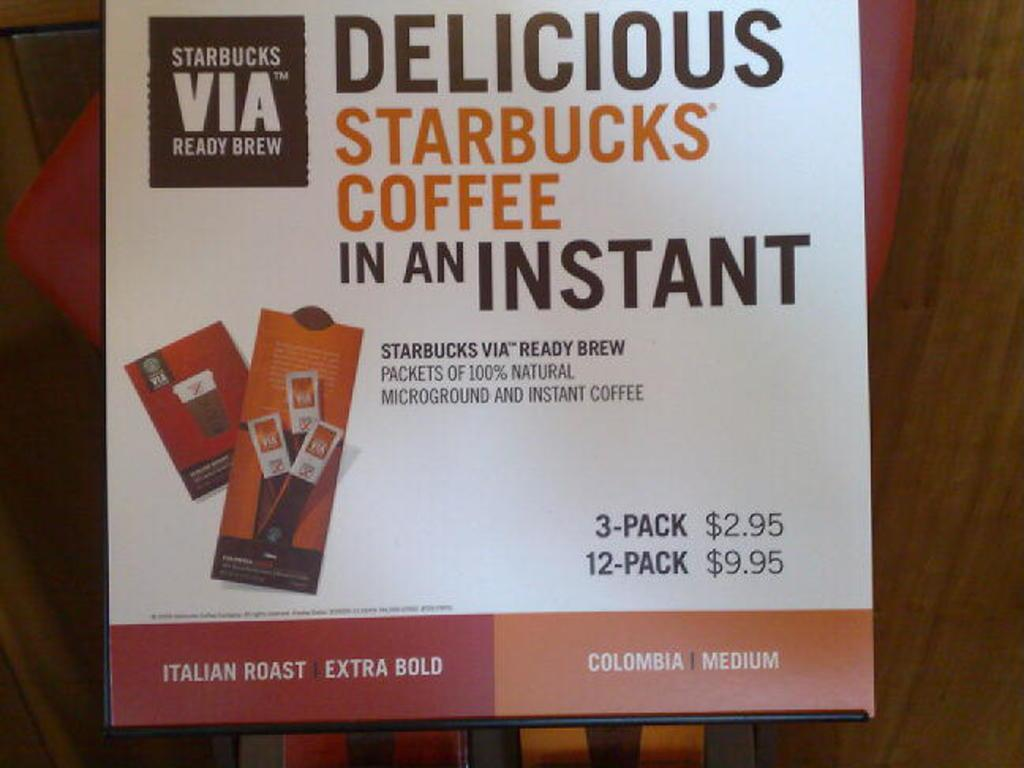<image>
Present a compact description of the photo's key features. A box of Starbucks Via coffee packs in Italian Roast and Colombia Medium flavors. 